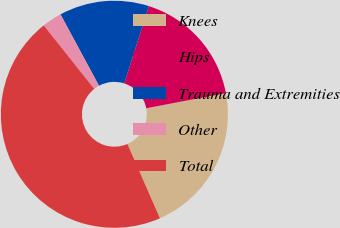<chart> <loc_0><loc_0><loc_500><loc_500><pie_chart><fcel>Knees<fcel>Hips<fcel>Trauma and Extremities<fcel>Other<fcel>Total<nl><fcel>21.41%<fcel>17.1%<fcel>12.79%<fcel>2.81%<fcel>45.89%<nl></chart> 